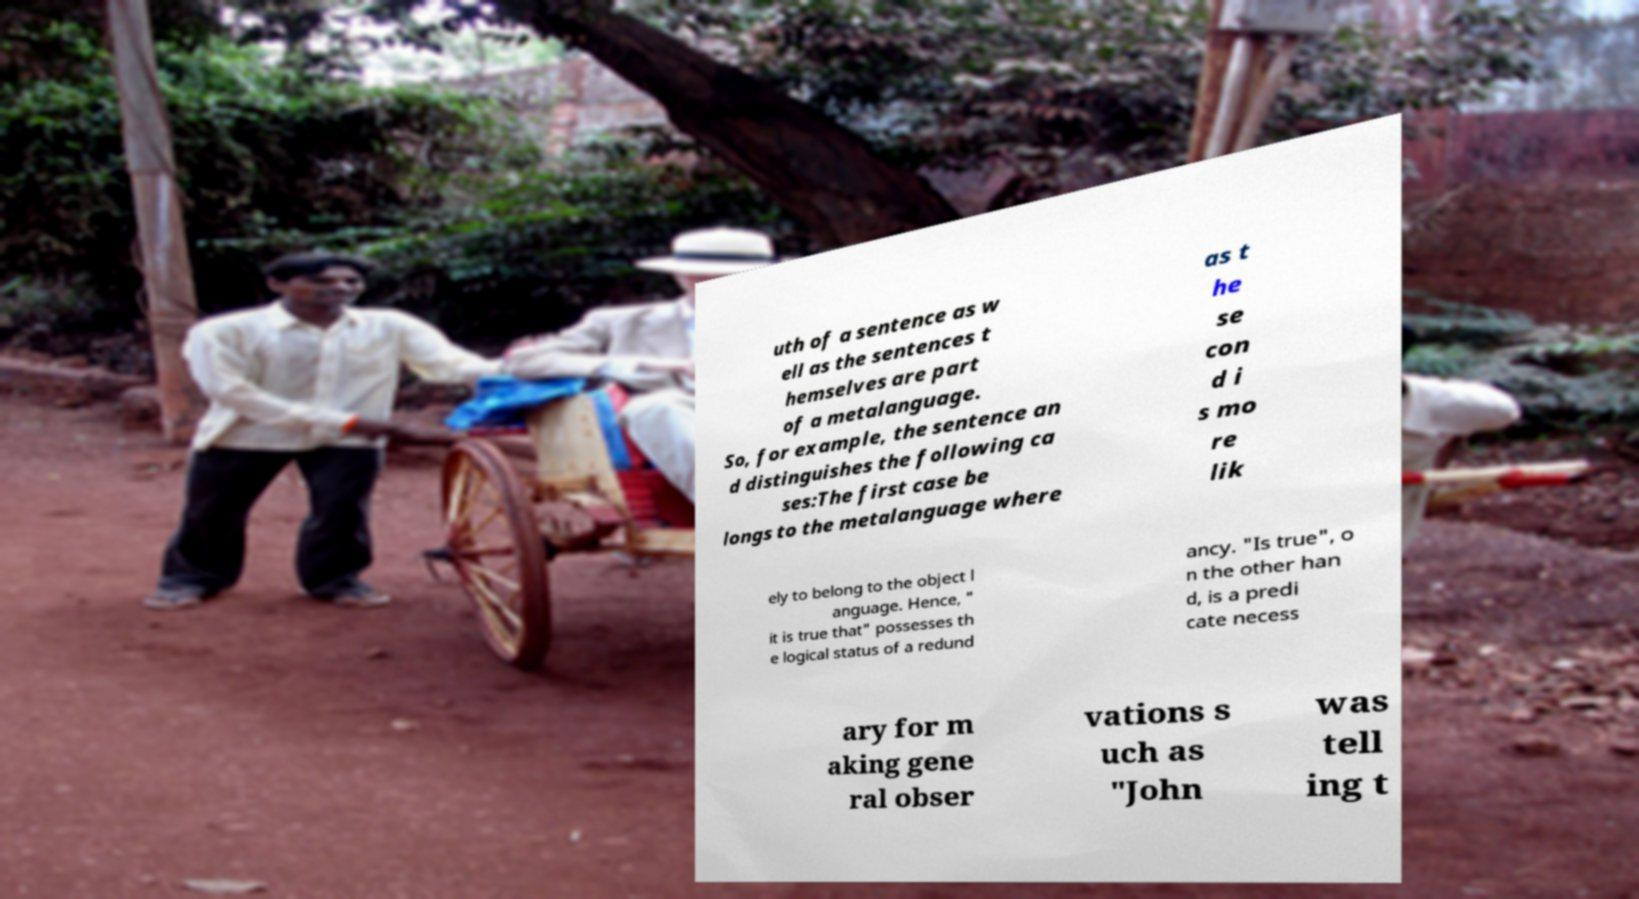There's text embedded in this image that I need extracted. Can you transcribe it verbatim? uth of a sentence as w ell as the sentences t hemselves are part of a metalanguage. So, for example, the sentence an d distinguishes the following ca ses:The first case be longs to the metalanguage where as t he se con d i s mo re lik ely to belong to the object l anguage. Hence, " it is true that" possesses th e logical status of a redund ancy. "Is true", o n the other han d, is a predi cate necess ary for m aking gene ral obser vations s uch as "John was tell ing t 